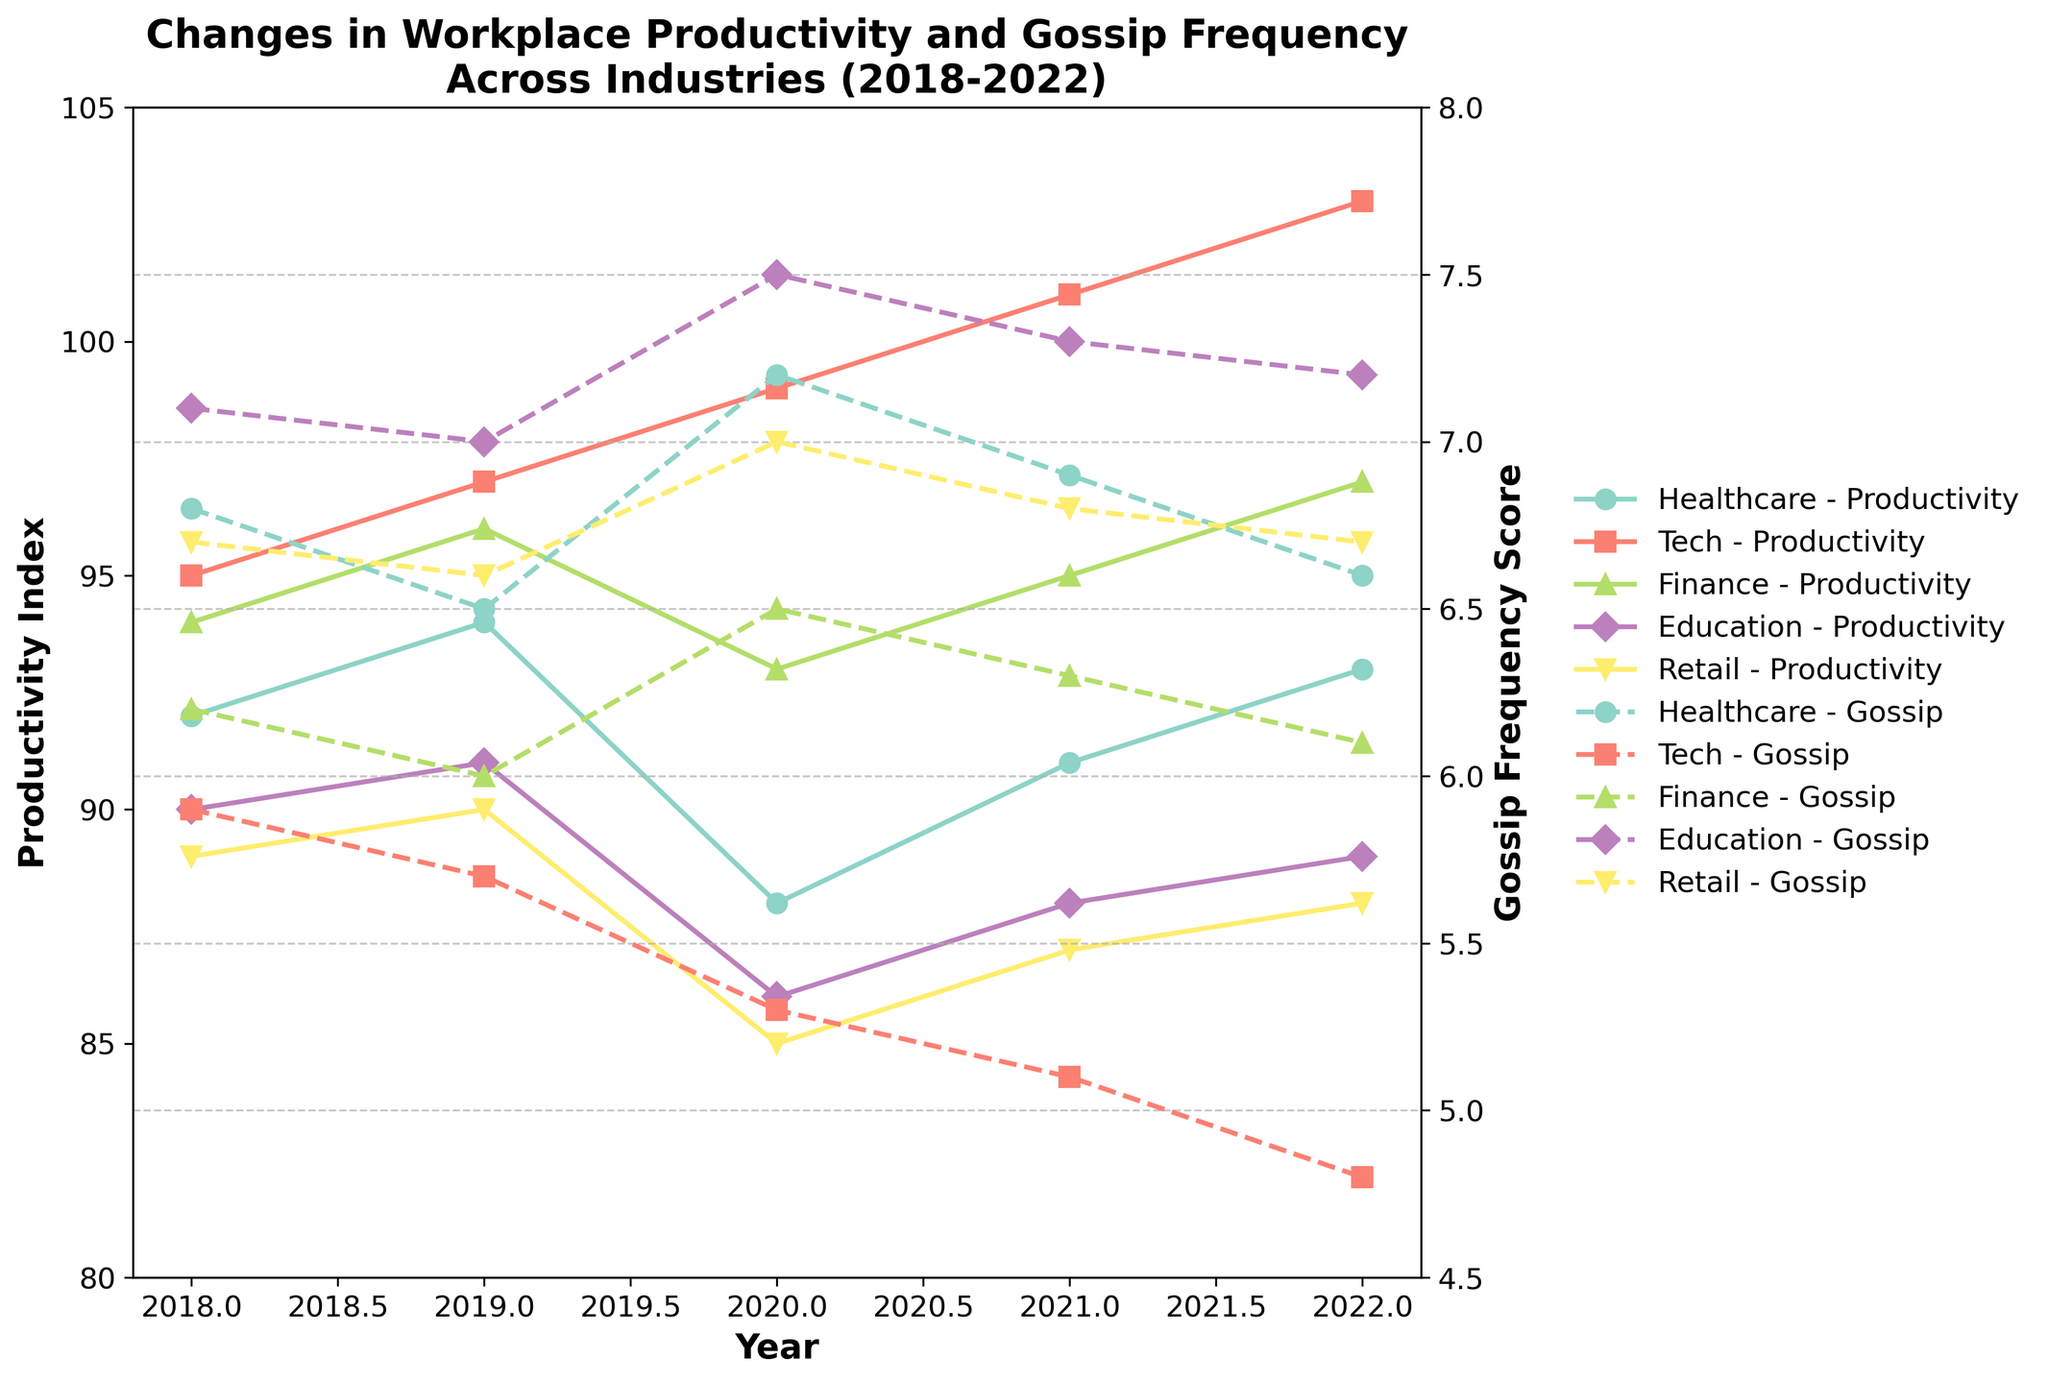What trend can be observed in the productivity index of the Tech industry from 2018 to 2022? The productivity index in the Tech industry steadily increases each year from 95 in 2018 to 103 in 2022.
Answer: Steady increase Which industry experienced the highest fluctuation in gossip frequency score from 2018 to 2022? By comparing the vertical ranges of the gossip frequency lines for each industry, the Healthcare and Education industries show the highest fluctuations, with a noticeable peak in 2020.
Answer: Healthcare and Education (both show fluctuations) Did any industry experience an increase in both productivity and gossip frequency score in the same year? Reviewing the figure, in 2020, the Healthcare industry shows a decrease in productivity index and an increase in gossip frequency. All other industries either have opposite changes or no simultaneous increase in both.
Answer: No Which industry had the highest productivity index in 2018? By looking at the starting points of the productivity lines in 2018, the Tech industry had the highest productivity index at 95.
Answer: Tech Compare the trend in gossip frequency score between the Tech and Finance industries. Which one shows a steeper decline? The Tech industry shows a steeper decline in gossip frequency score from 5.9 to 4.8, while the Finance industry shows a less steep decline from 6.2 to 6.1.
Answer: Tech Which year did the Education industry experience the sharpest drop in productivity index? The productivity index for the Education industry has the largest decrease from 91 in 2019 to 86 in 2020.
Answer: 2020 What is the difference in gossip frequency score for the Healthcare industry between the years 2020 and 2021? The gossip frequency score for the Healthcare industry decreases from 7.2 in 2020 to 6.9 in 2021, a difference of 0.3.
Answer: 0.3 Calculate the average productivity index for the Retail industry over the 5 years period. Adding the yearly values: 89 (2018), 90 (2019), 85 (2020), 87 (2021), 88 (2022). The total is 439. Dividing by 5, the average productivity index is 87.8.
Answer: 87.8 Which industry had the lowest gossip frequency score in 2022? The lowest gossip frequency score in 2022 is for the Tech industry at 4.8.
Answer: Tech In which year did the Finance industry have equal productivity index and gossip frequency score? In the line chart, the gossip frequency and productivity index for the Finance industry never match in any given year.
Answer: None 